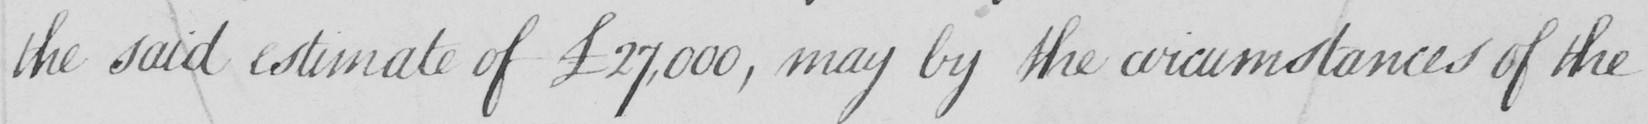What is written in this line of handwriting? the said estimate of £27,000 , may by the circumstances of the 